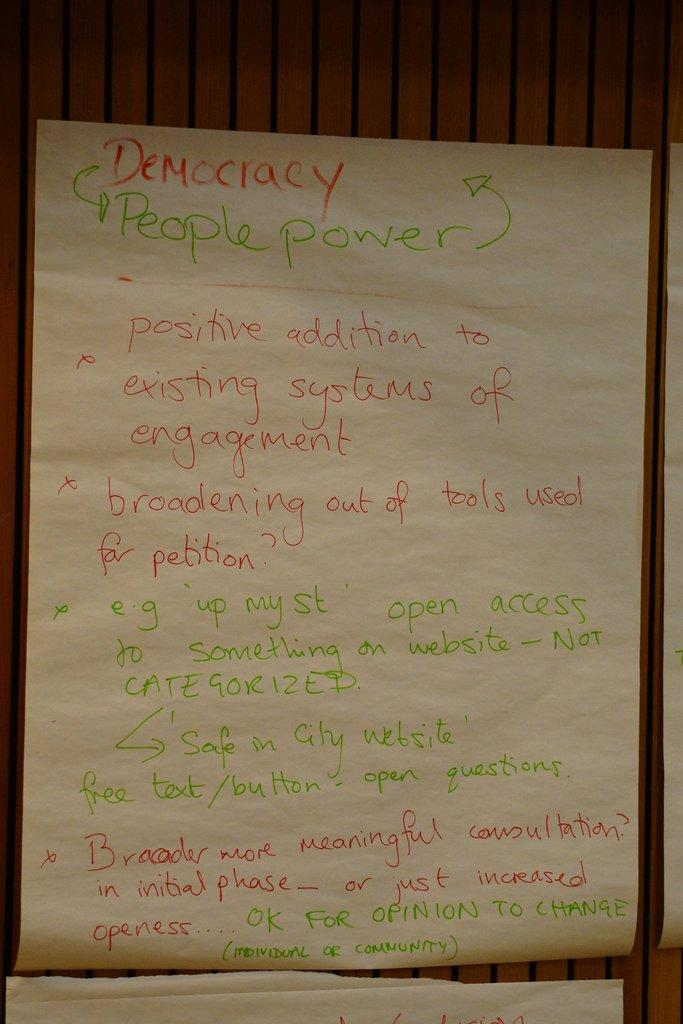<image>
Present a compact description of the photo's key features. A paper has hand written notes on it that says Democracy People Power. 